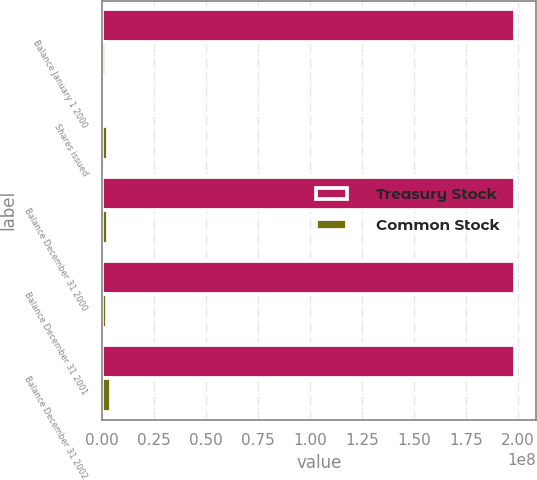Convert chart to OTSL. <chart><loc_0><loc_0><loc_500><loc_500><stacked_bar_chart><ecel><fcel>Balance January 1 2000<fcel>Shares issued<fcel>Balance December 31 2000<fcel>Balance December 31 2001<fcel>Balance December 31 2002<nl><fcel>Treasury Stock<fcel>1.98728e+08<fcel>50000<fcel>1.98778e+08<fcel>1.98798e+08<fcel>1.988e+08<nl><fcel>Common Stock<fcel>1.84746e+06<fcel>2.72244e+06<fcel>2.68055e+06<fcel>2.4996e+06<fcel>4.30092e+06<nl></chart> 